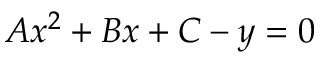<formula> <loc_0><loc_0><loc_500><loc_500>A x ^ { 2 } + B x + C - y = 0</formula> 